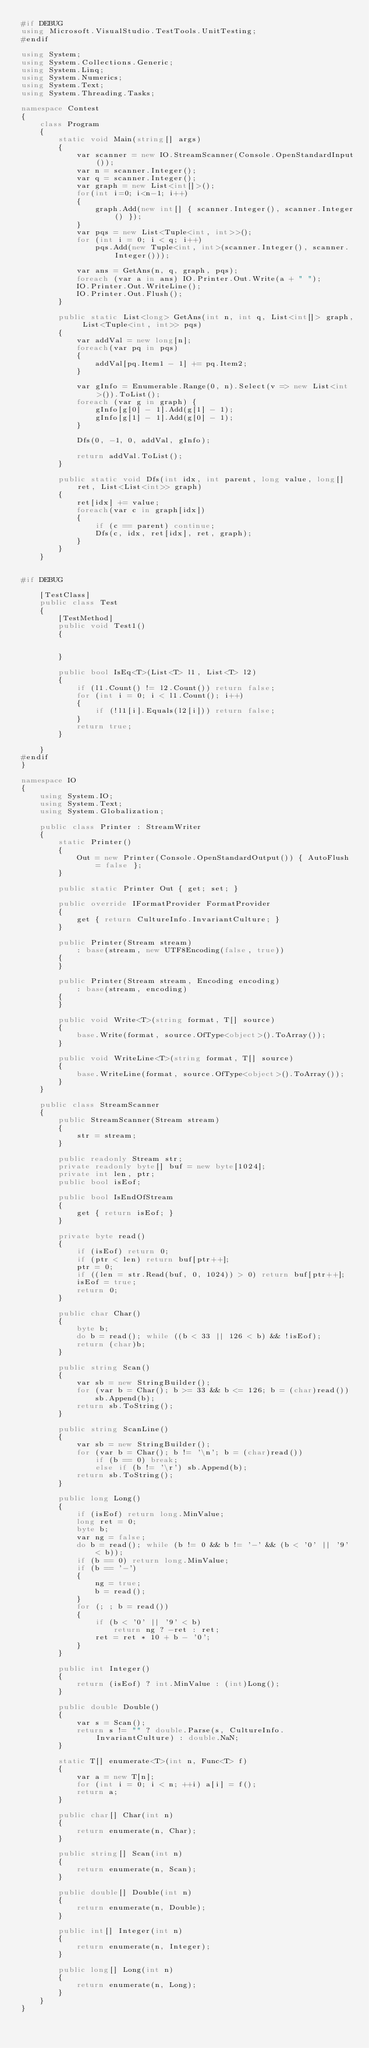<code> <loc_0><loc_0><loc_500><loc_500><_C#_>#if DEBUG
using Microsoft.VisualStudio.TestTools.UnitTesting;
#endif

using System;
using System.Collections.Generic;
using System.Linq;
using System.Numerics;
using System.Text;
using System.Threading.Tasks;

namespace Contest
{
    class Program
    {
        static void Main(string[] args)
        {
            var scanner = new IO.StreamScanner(Console.OpenStandardInput());
            var n = scanner.Integer();
            var q = scanner.Integer();
            var graph = new List<int[]>();
            for(int i=0; i<n-1; i++)
            {
                graph.Add(new int[] { scanner.Integer(), scanner.Integer() });
            }
            var pqs = new List<Tuple<int, int>>();
            for (int i = 0; i < q; i++)
                pqs.Add(new Tuple<int, int>(scanner.Integer(), scanner.Integer()));

            var ans = GetAns(n, q, graph, pqs);
            foreach (var a in ans) IO.Printer.Out.Write(a + " ");
            IO.Printer.Out.WriteLine();
            IO.Printer.Out.Flush();
        }

        public static List<long> GetAns(int n, int q, List<int[]> graph, List<Tuple<int, int>> pqs)
        {
            var addVal = new long[n];
            foreach(var pq in pqs)
            {
                addVal[pq.Item1 - 1] += pq.Item2;
            }

            var gInfo = Enumerable.Range(0, n).Select(v => new List<int>()).ToList();
            foreach (var g in graph) {
                gInfo[g[0] - 1].Add(g[1] - 1);
                gInfo[g[1] - 1].Add(g[0] - 1);
            }

            Dfs(0, -1, 0, addVal, gInfo);

            return addVal.ToList();
        }

        public static void Dfs(int idx, int parent, long value, long[] ret, List<List<int>> graph)
        {
            ret[idx] += value;
            foreach(var c in graph[idx])
            {
                if (c == parent) continue;
                Dfs(c, idx, ret[idx], ret, graph);
            }
        }
    }


#if DEBUG

    [TestClass]
    public class Test
    {
        [TestMethod]
        public void Test1()
        {


        }

        public bool IsEq<T>(List<T> l1, List<T> l2)
        {
            if (l1.Count() != l2.Count()) return false;
            for (int i = 0; i < l1.Count(); i++)
            {
                if (!l1[i].Equals(l2[i])) return false;
            }
            return true;
        }

    }
#endif
}

namespace IO
{
    using System.IO;
    using System.Text;
    using System.Globalization;

    public class Printer : StreamWriter
    {
        static Printer()
        {
            Out = new Printer(Console.OpenStandardOutput()) { AutoFlush = false };
        }

        public static Printer Out { get; set; }

        public override IFormatProvider FormatProvider
        {
            get { return CultureInfo.InvariantCulture; }
        }

        public Printer(Stream stream)
            : base(stream, new UTF8Encoding(false, true))
        {
        }

        public Printer(Stream stream, Encoding encoding)
            : base(stream, encoding)
        {
        }

        public void Write<T>(string format, T[] source)
        {
            base.Write(format, source.OfType<object>().ToArray());
        }

        public void WriteLine<T>(string format, T[] source)
        {
            base.WriteLine(format, source.OfType<object>().ToArray());
        }
    }

    public class StreamScanner
    {
        public StreamScanner(Stream stream)
        {
            str = stream;
        }

        public readonly Stream str;
        private readonly byte[] buf = new byte[1024];
        private int len, ptr;
        public bool isEof;

        public bool IsEndOfStream
        {
            get { return isEof; }
        }

        private byte read()
        {
            if (isEof) return 0;
            if (ptr < len) return buf[ptr++];
            ptr = 0;
            if ((len = str.Read(buf, 0, 1024)) > 0) return buf[ptr++];
            isEof = true;
            return 0;
        }

        public char Char()
        {
            byte b;
            do b = read(); while ((b < 33 || 126 < b) && !isEof);
            return (char)b;
        }

        public string Scan()
        {
            var sb = new StringBuilder();
            for (var b = Char(); b >= 33 && b <= 126; b = (char)read())
                sb.Append(b);
            return sb.ToString();
        }

        public string ScanLine()
        {
            var sb = new StringBuilder();
            for (var b = Char(); b != '\n'; b = (char)read())
                if (b == 0) break;
                else if (b != '\r') sb.Append(b);
            return sb.ToString();
        }

        public long Long()
        {
            if (isEof) return long.MinValue;
            long ret = 0;
            byte b;
            var ng = false;
            do b = read(); while (b != 0 && b != '-' && (b < '0' || '9' < b));
            if (b == 0) return long.MinValue;
            if (b == '-')
            {
                ng = true;
                b = read();
            }
            for (; ; b = read())
            {
                if (b < '0' || '9' < b)
                    return ng ? -ret : ret;
                ret = ret * 10 + b - '0';
            }
        }

        public int Integer()
        {
            return (isEof) ? int.MinValue : (int)Long();
        }

        public double Double()
        {
            var s = Scan();
            return s != "" ? double.Parse(s, CultureInfo.InvariantCulture) : double.NaN;
        }

        static T[] enumerate<T>(int n, Func<T> f)
        {
            var a = new T[n];
            for (int i = 0; i < n; ++i) a[i] = f();
            return a;
        }

        public char[] Char(int n)
        {
            return enumerate(n, Char);
        }

        public string[] Scan(int n)
        {
            return enumerate(n, Scan);
        }

        public double[] Double(int n)
        {
            return enumerate(n, Double);
        }

        public int[] Integer(int n)
        {
            return enumerate(n, Integer);
        }

        public long[] Long(int n)
        {
            return enumerate(n, Long);
        }
    }
}
</code> 